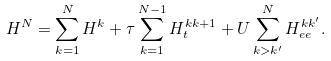Convert formula to latex. <formula><loc_0><loc_0><loc_500><loc_500>H ^ { N } = \sum _ { k = 1 } ^ { N } H ^ { k } + \tau \sum _ { k = 1 } ^ { N - 1 } H _ { t } ^ { k k + 1 } + U \sum _ { k > k ^ { \prime } } ^ { N } H _ { e e } ^ { k k ^ { \prime } } .</formula> 